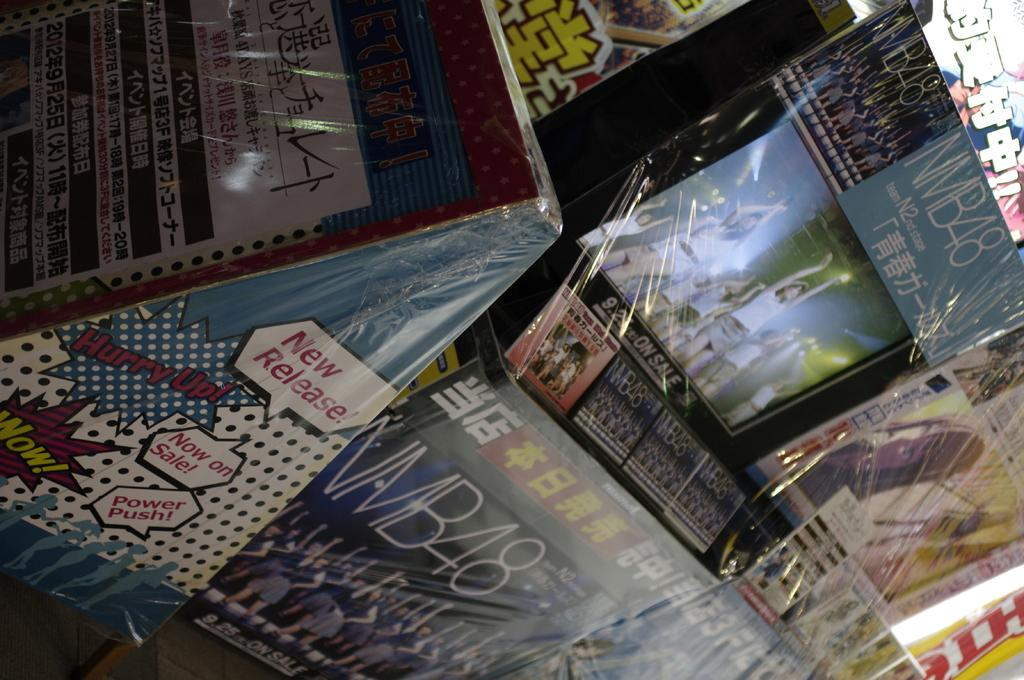<image>
Give a short and clear explanation of the subsequent image. A comic book display reads "Hurry up! Now on Sale! 